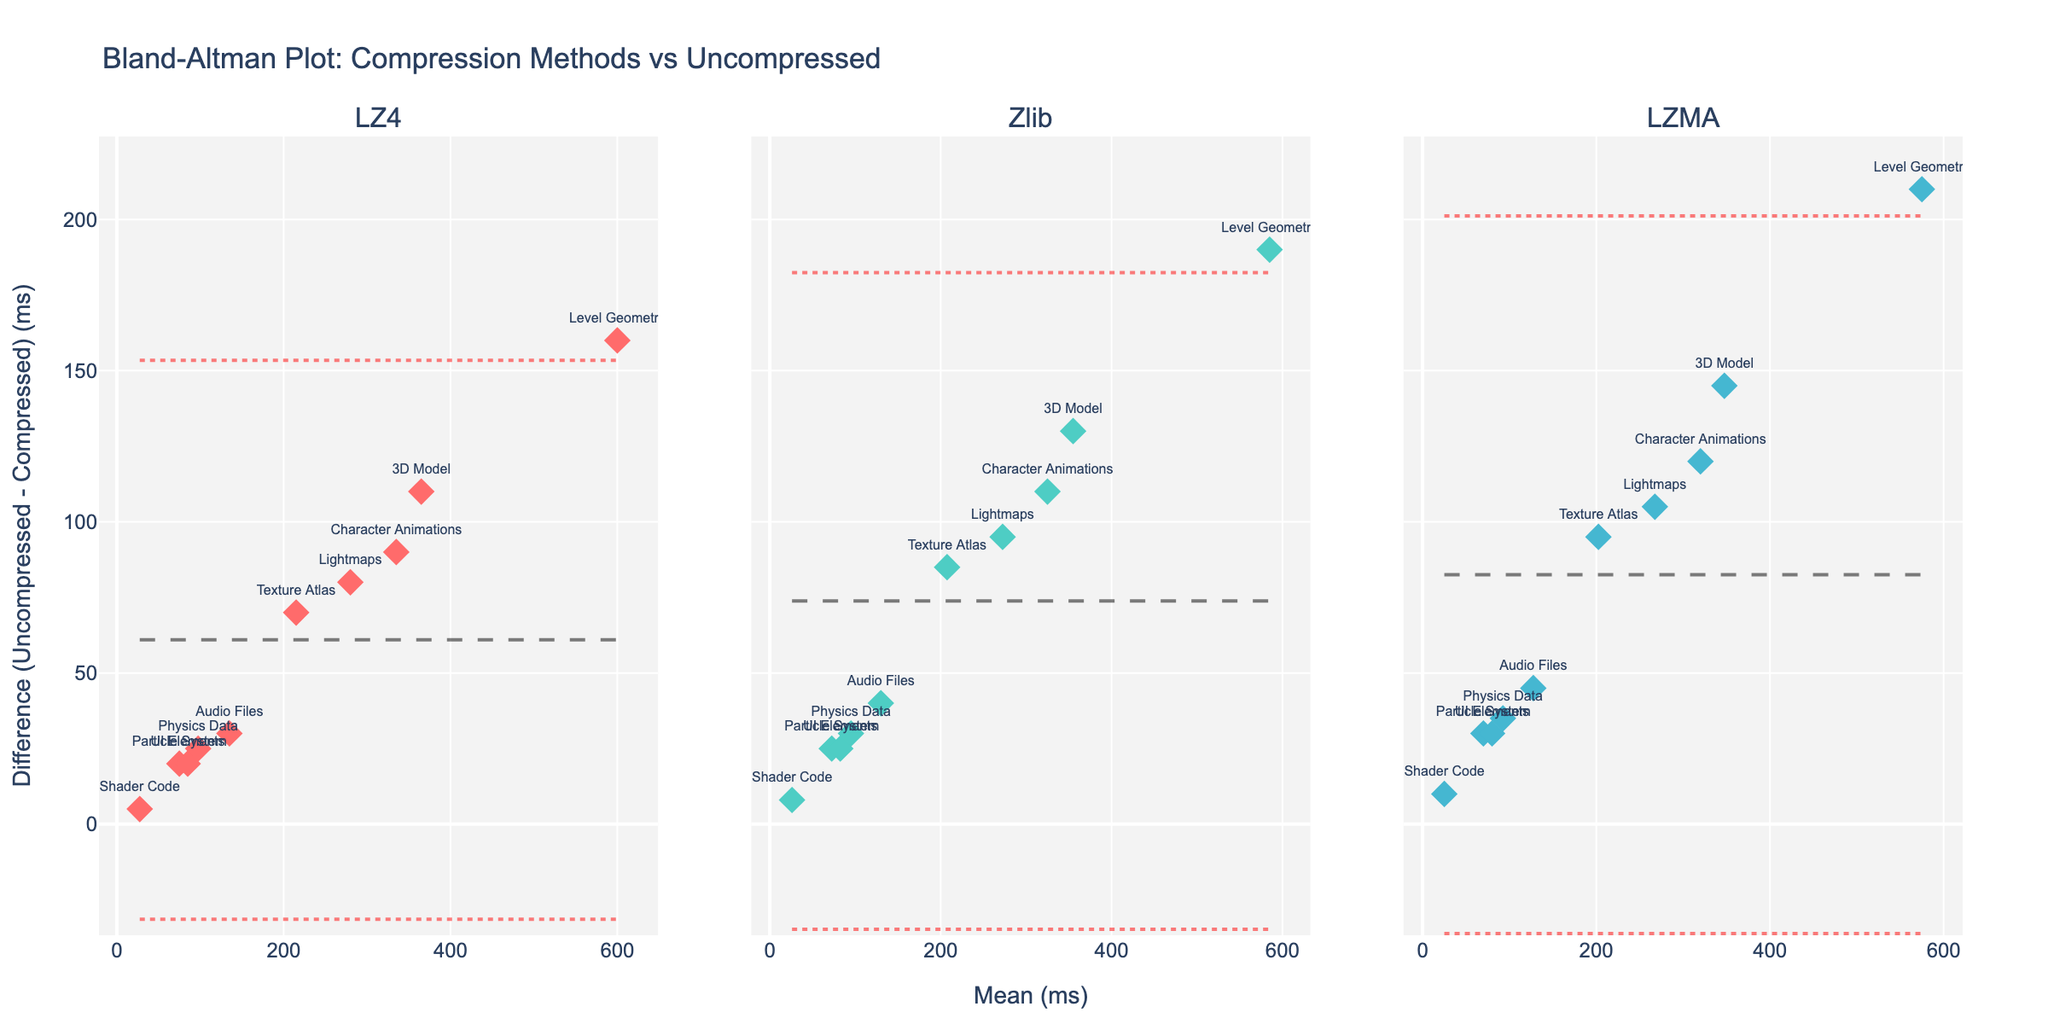what is the title of the plot? Look at the top of the figure where the title is usually placed. The title is written as 'Bland-Altman Plot: Compression Methods vs Uncompressed'
Answer: Bland-Altman Plot: Compression Methods vs Uncompressed How many data points are represented for each compression method? Count the number of markers displayed for each subplot representing LZ4, Zlib, and LZMA. All the subplots should have an equal number of markers as per the provided data. Every method has 10 data points.
Answer: 10 What does the y-axis represent in the plot? The y-axis is typically labeled on the left side of the plot, showing the measurement it represents. Here, the y-axis shows 'Difference (Uncompressed - Compressed) (ms)'.
Answer: Difference (Uncompressed - Compressed) (ms) Which method shows the smallest mean difference in loading time? Observe the mean lines (dashed black lines) in each subplot and check which one is closest to zero. The LZMA method has its mean line closest to zero.
Answer: LZMA Which method has the widest limits of agreement (LoA)? Look for the red dotted lines marking the limits of agreement in each subplot. Compare the distances between these lines for each method. LZ4 has the widest limits of agreement.
Answer: LZ4 What is the mean difference for the Zlib method? Look at the dashed black line in the Zlib subplot, which marks the mean difference value on the y-axis. It intersects at around 95 ms.
Answer: 95 ms Between which values do the limits of agreement for the LZMA method lie? Identify the upper and lower red dotted lines in the LZMA subplot and note their intersection with the y-axis. They lie approximately between 85 ms and 210 ms.
Answer: 85 ms and 210 ms What is the difference in load times for the 'Level Geometry' asset using the LZ4 method? Find the 'Level Geometry' label in the LZ4 subplot and see its position on the y-axis. It is around 160 ms.
Answer: 160 ms Which compression method has the smallest standard deviation in the difference of load times? Visually estimate which method has the least spread in differences around the mean difference line. LZMA seems to have the least spread or variability.
Answer: LZMA Is there a trend in the differences as the mean load time increases for any method? Visually inspect if there is a pattern or trend in the scatter for each method as the values move from left to right (mean load time increases). No clear trend is observed for any method.
Answer: No 